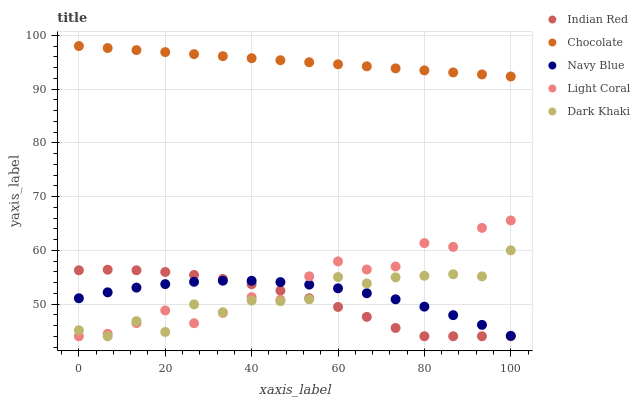Does Indian Red have the minimum area under the curve?
Answer yes or no. Yes. Does Chocolate have the maximum area under the curve?
Answer yes or no. Yes. Does Navy Blue have the minimum area under the curve?
Answer yes or no. No. Does Navy Blue have the maximum area under the curve?
Answer yes or no. No. Is Chocolate the smoothest?
Answer yes or no. Yes. Is Dark Khaki the roughest?
Answer yes or no. Yes. Is Navy Blue the smoothest?
Answer yes or no. No. Is Navy Blue the roughest?
Answer yes or no. No. Does Light Coral have the lowest value?
Answer yes or no. Yes. Does Navy Blue have the lowest value?
Answer yes or no. No. Does Chocolate have the highest value?
Answer yes or no. Yes. Does Dark Khaki have the highest value?
Answer yes or no. No. Is Dark Khaki less than Chocolate?
Answer yes or no. Yes. Is Chocolate greater than Light Coral?
Answer yes or no. Yes. Does Light Coral intersect Navy Blue?
Answer yes or no. Yes. Is Light Coral less than Navy Blue?
Answer yes or no. No. Is Light Coral greater than Navy Blue?
Answer yes or no. No. Does Dark Khaki intersect Chocolate?
Answer yes or no. No. 